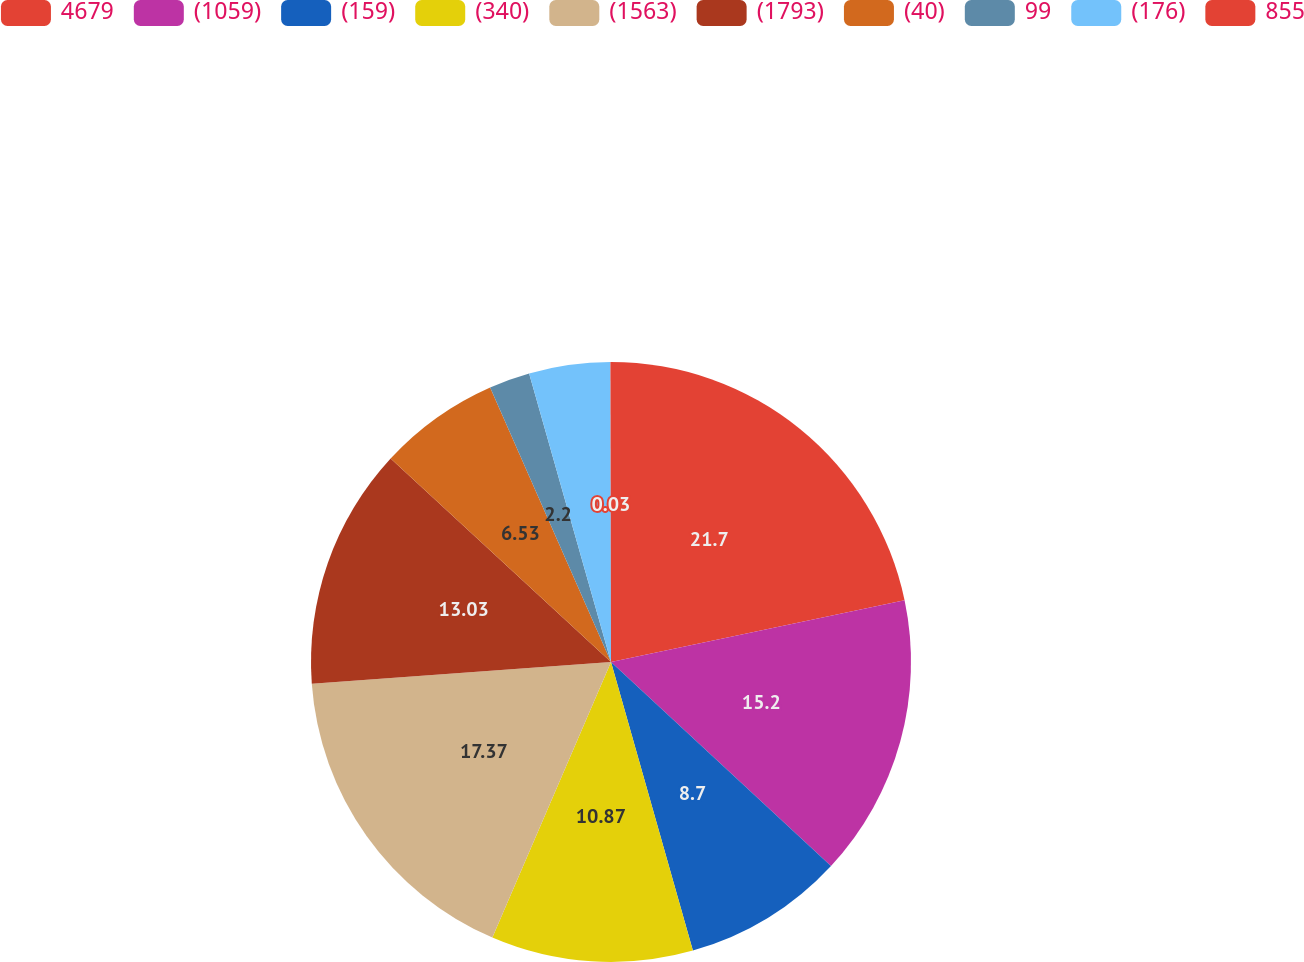Convert chart to OTSL. <chart><loc_0><loc_0><loc_500><loc_500><pie_chart><fcel>4679<fcel>(1059)<fcel>(159)<fcel>(340)<fcel>(1563)<fcel>(1793)<fcel>(40)<fcel>99<fcel>(176)<fcel>855<nl><fcel>21.7%<fcel>15.2%<fcel>8.7%<fcel>10.87%<fcel>17.37%<fcel>13.03%<fcel>6.53%<fcel>2.2%<fcel>4.37%<fcel>0.03%<nl></chart> 